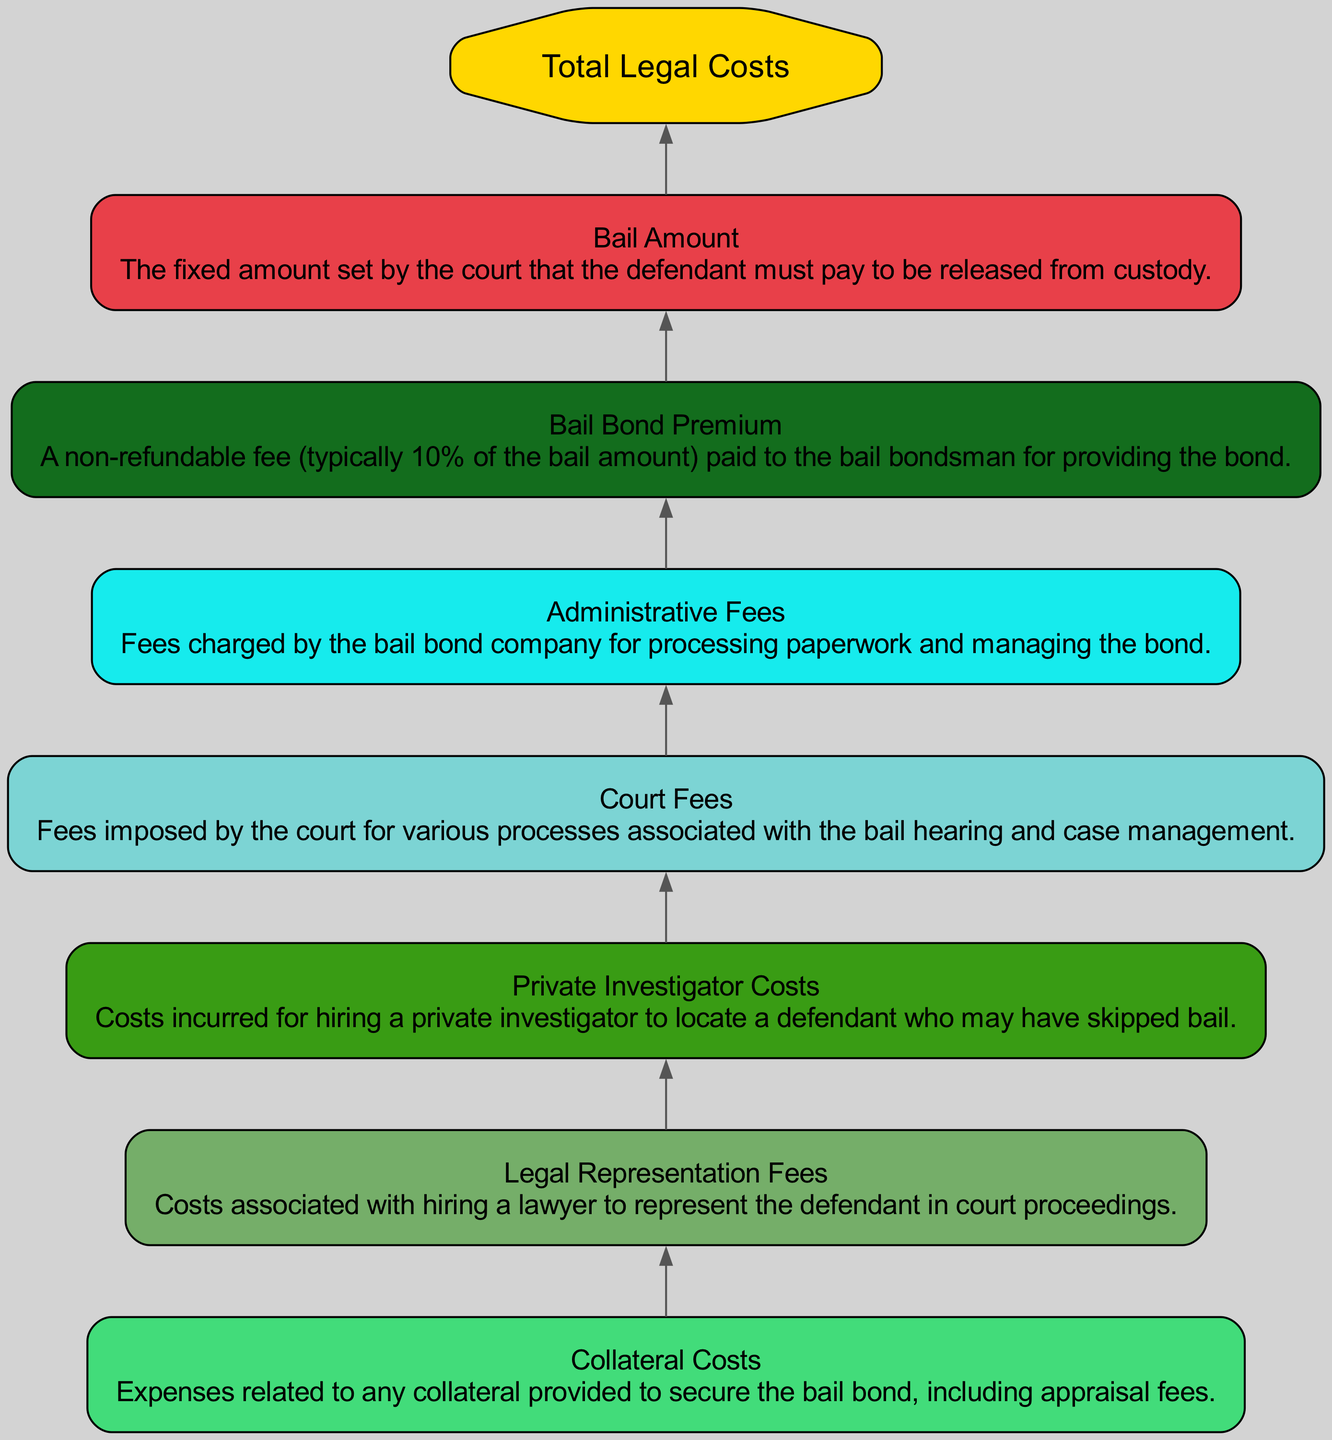What is the top node of the diagram? The top node in a bottom-up flow chart represents the highest summary of information, which in this case is "Total Legal Costs."
Answer: Total Legal Costs How many elements are listed in the diagram? By counting each of the individual components outlined in the diagram, we find there are seven distinct elements contributing to legal costs during the bail process.
Answer: 7 What fee is a percentage of the bail amount? The "Bail Bond Premium" is mentioned as a fee that is typically 10% of the bail amount set by the court, thus it is a direct percentage of that value.
Answer: Bail Bond Premium Which cost is associated with securing a bail bond? The "Collateral Costs" are explicitly mentioned as expenses related to any collateral that is provided to secure a bail bond, making it integral to this process.
Answer: Collateral Costs What costs may arise from a defendant skipping bail? If a defendant skips bail, the "Private Investigator Costs" become relevant as they pertain to the expenses incurred in locating the missing defendant.
Answer: Private Investigator Costs Which two costs are associated with court processes? The diagram mentions "Court Fees" and "Legal Representation Fees," both of which are linked to expenses incurred during court-related activities.
Answer: Court Fees, Legal Representation Fees Which element is the non-refundable fee? The "Bail Bond Premium" is specifically identified as a non-refundable fee, charged by the bail bondsman for providing the bond, distinguishing it from other costs that may be refundable.
Answer: Bail Bond Premium What kind of expenses does the "Administrative Fees" cover? "Administrative Fees" encompass the costs associated with processing paperwork and managing the bond, capturing overhead for operational tasks performed by the bail bond company.
Answer: Processing paperwork Explain the relationship between "Bail Amount" and "Bail Bond Premium." The "Bail Bond Premium" directly derives from the "Bail Amount," as it is typically computed as a non-refundable fee amounting to 10% of the total bail amount set by the court. Therefore, the relationship shows that the premium is a portion of the larger bail amount.
Answer: Bail Bond Premium is 10% of Bail Amount 